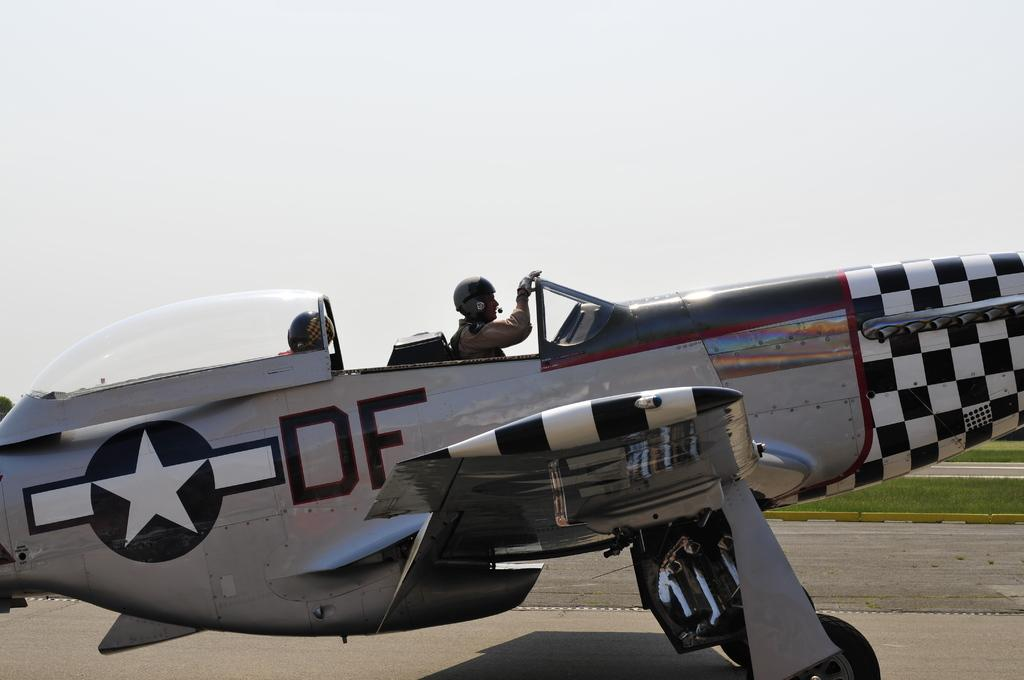How many people are sitting on the plane in the image? There are two persons sitting on the plane in the image. Where is the plane located in the image? The plane is on the road in the image. What type of vegetation can be seen in the background? There is grass on the ground in the background. What is visible in the sky in the image? The sky is visible in the background of the image. What is located on the left side of the image? There is a tree on the left side of the image. How many pizzas are being served on the plane in the image? There is no mention of pizzas in the image; it features a plane on the road with two persons sitting on it. 